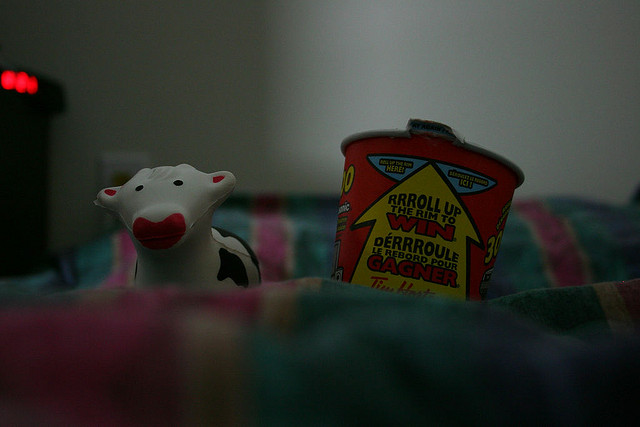<image>What color are the stripes on the teddy bear? It is unknown what color the stripes on the teddy bear are. It may not be shown in the image. What color are the stripes on the teddy bear? It is unknown what color are the stripes on the teddy bear. 